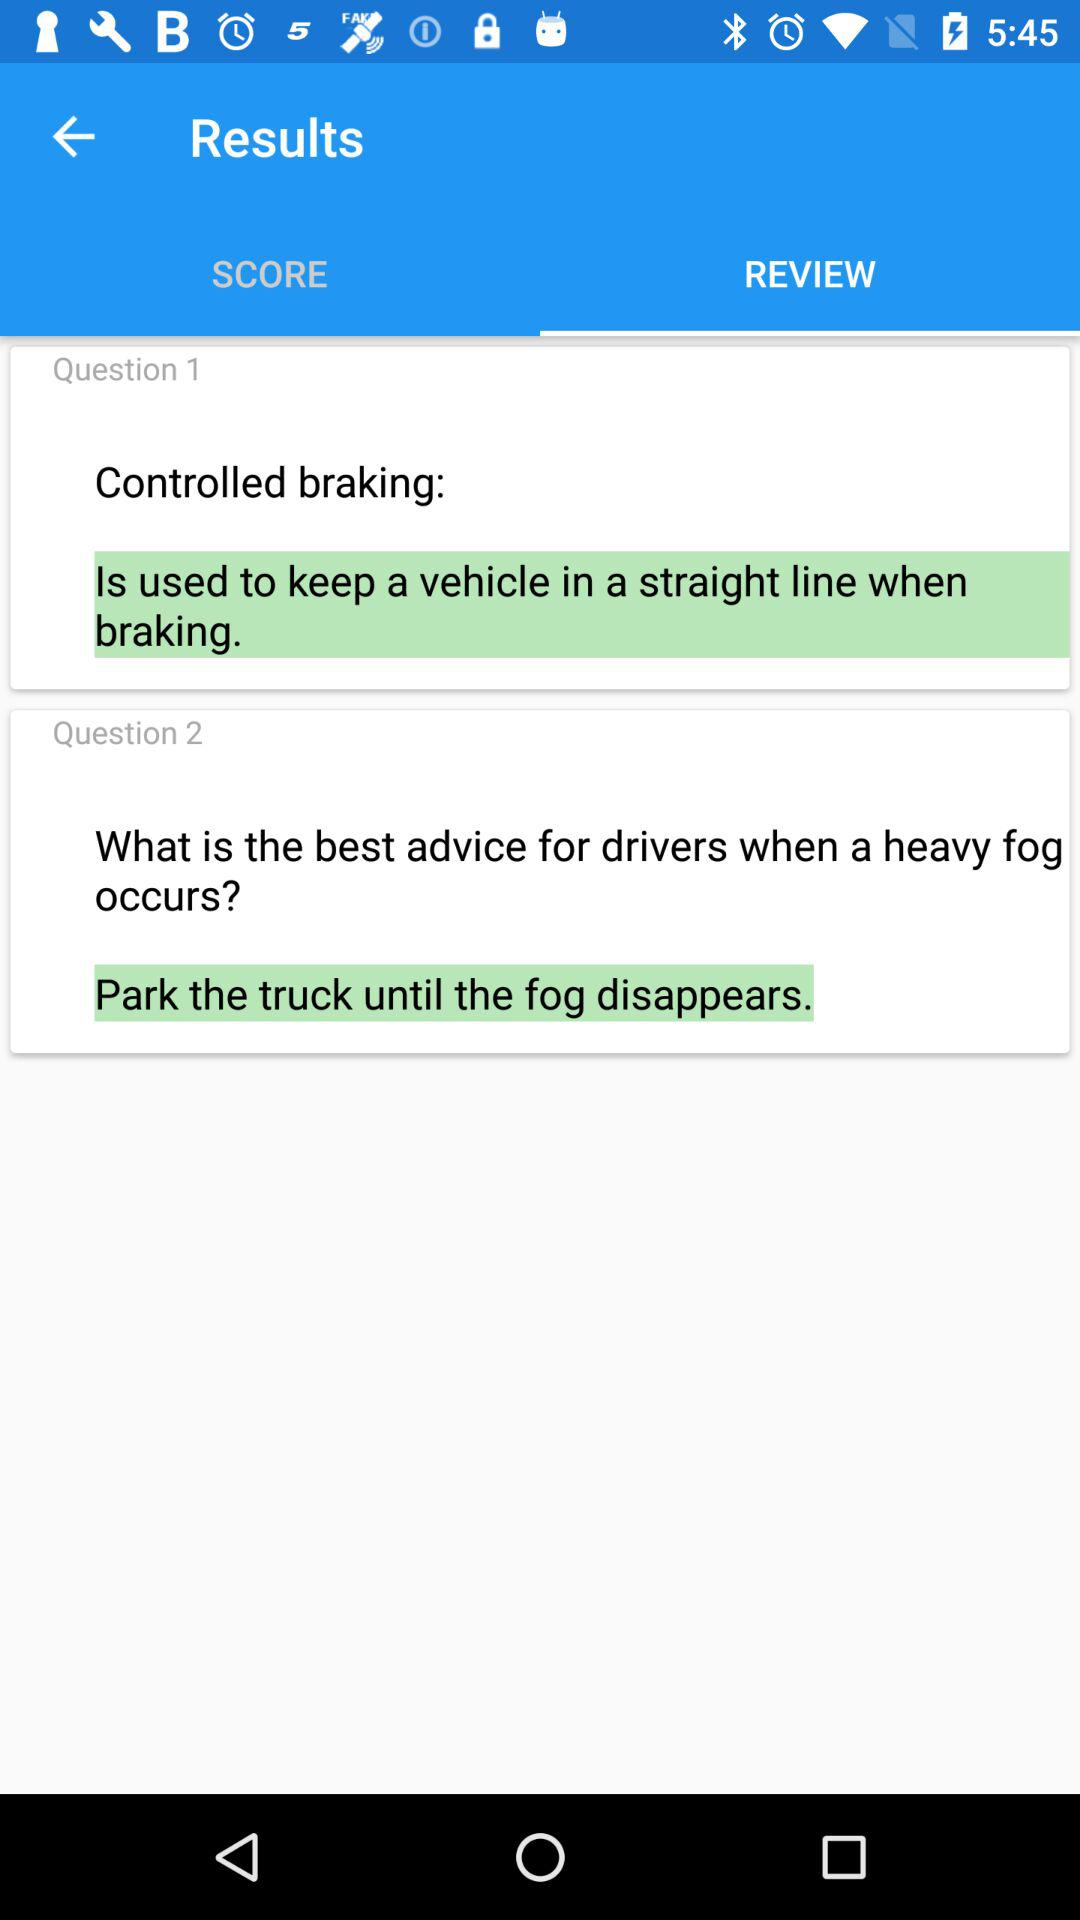How many questions are there in this quiz?
Answer the question using a single word or phrase. 2 